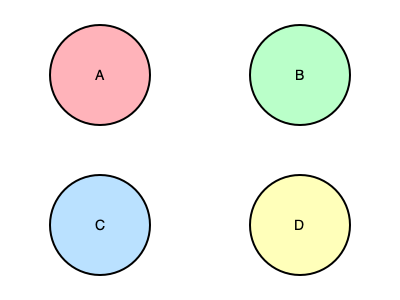Based on the microscopic images of animal cells shown above, which cell type is most likely to be involved in the production and secretion of digestive enzymes in the pancreas? To identify the cell type involved in the production and secretion of digestive enzymes in the pancreas, we need to analyze the characteristics of each cell:

1. Cell A (top left, pink): This cell has a large, centrally located nucleus and minimal cytoplasm. These features are typical of lymphocytes, which are not involved in enzyme production.

2. Cell B (top right, light green): This cell shows numerous small, dark granules in the cytoplasm. This appearance is characteristic of pancreatic acinar cells, which are responsible for producing and secreting digestive enzymes.

3. Cell C (bottom left, light blue): This cell has a bi-lobed nucleus and granules in the cytoplasm. These features are typical of neutrophils, which are white blood cells involved in immune responses.

4. Cell D (bottom right, light yellow): This cell has a large, eccentric nucleus and a moderate amount of cytoplasm. These characteristics are consistent with plasma cells, which produce antibodies.

Among these cell types, pancreatic acinar cells (Cell B) are specifically designed for the production and secretion of digestive enzymes. They have a distinctive appearance with numerous zymogen granules in the cytoplasm, which contain the precursors of digestive enzymes.
Answer: Cell B (pancreatic acinar cell) 